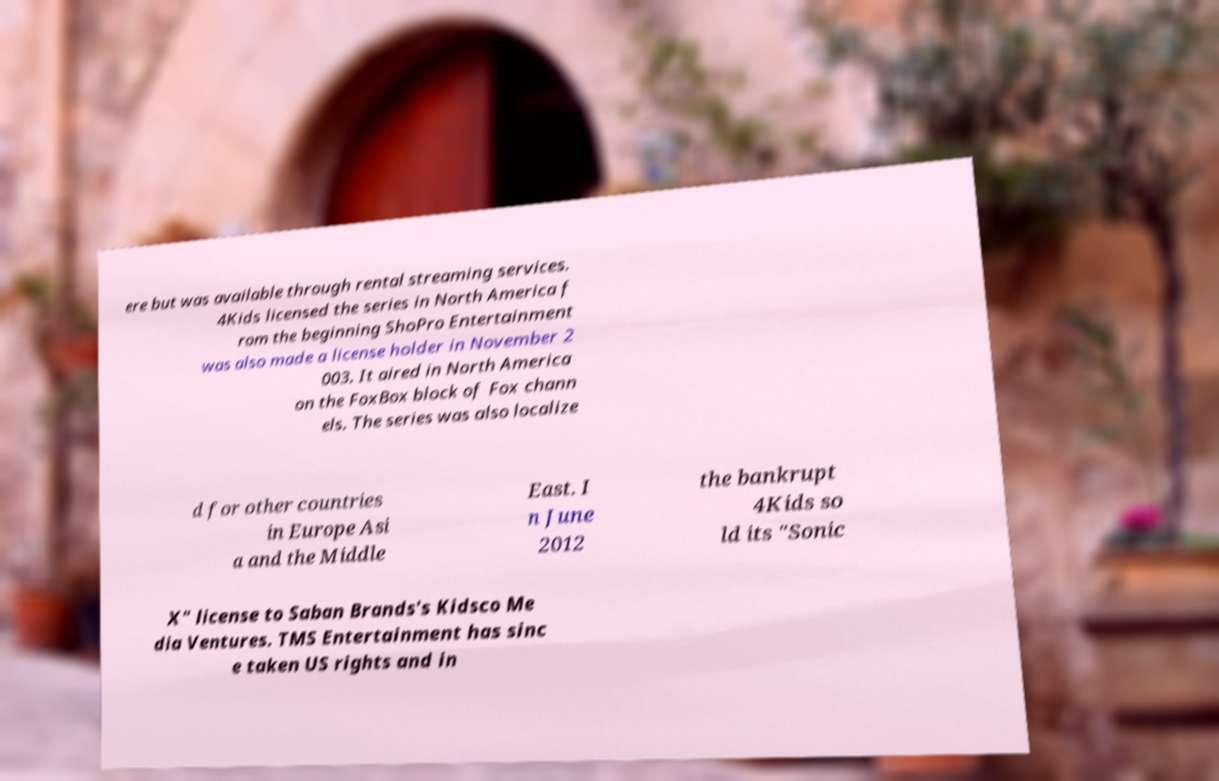For documentation purposes, I need the text within this image transcribed. Could you provide that? ere but was available through rental streaming services. 4Kids licensed the series in North America f rom the beginning ShoPro Entertainment was also made a license holder in November 2 003. It aired in North America on the FoxBox block of Fox chann els. The series was also localize d for other countries in Europe Asi a and the Middle East. I n June 2012 the bankrupt 4Kids so ld its "Sonic X" license to Saban Brands's Kidsco Me dia Ventures. TMS Entertainment has sinc e taken US rights and in 